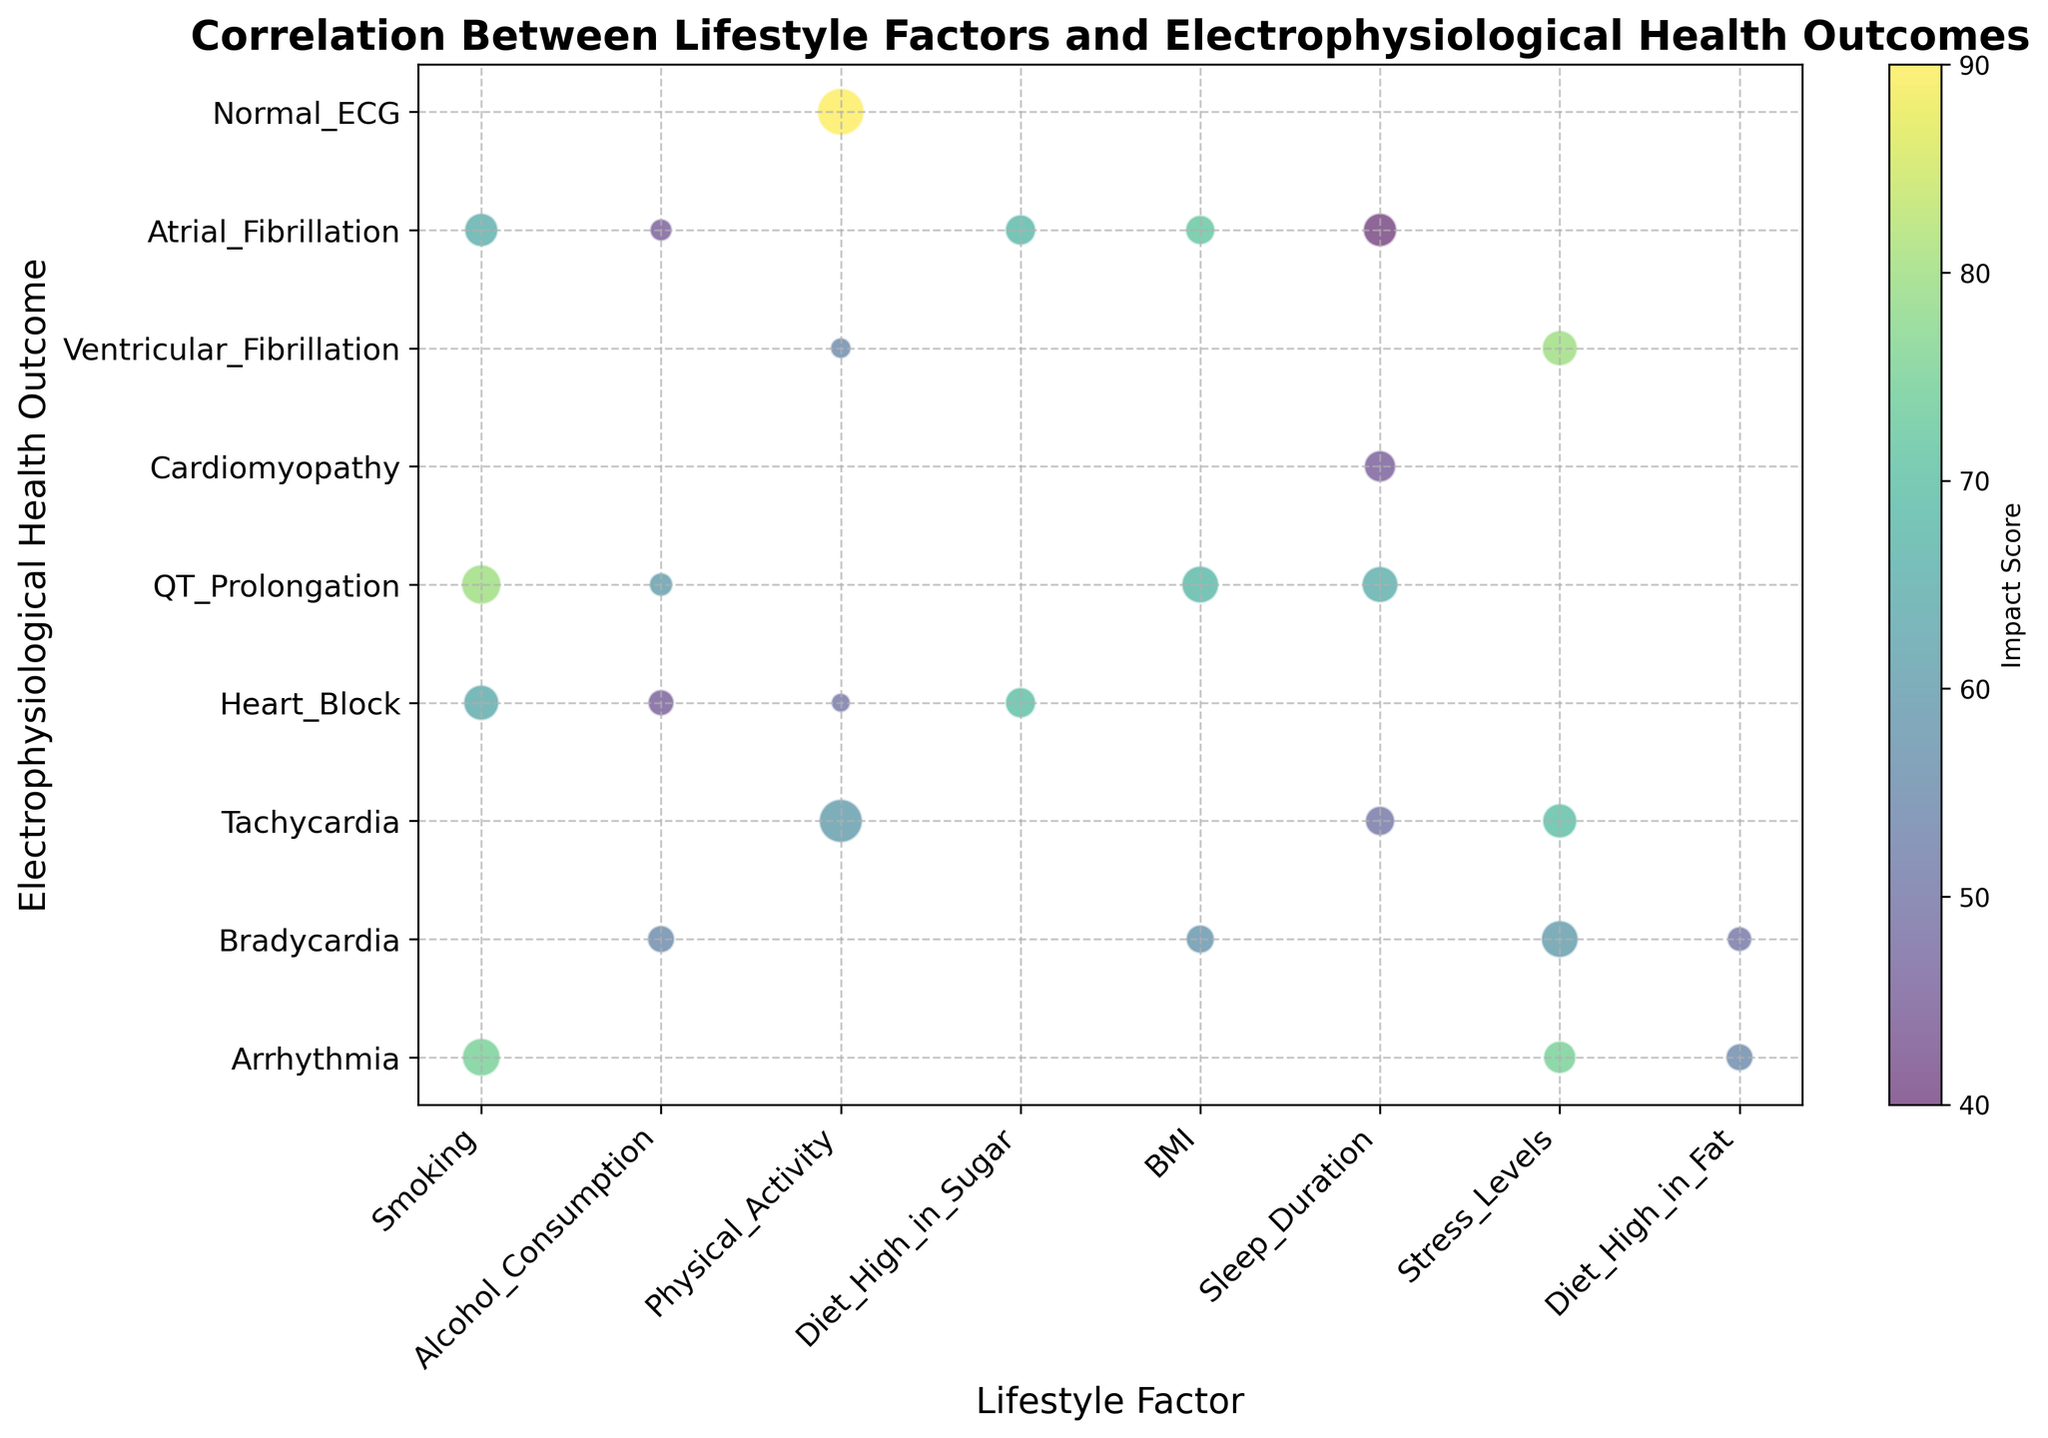What Lifestyle Factor is associated with the highest Frequency of Occurrence for QT Prolongation? To find this, we look for the bubble(s) related to QT Prolongation and identify which one is the largest. For QT Prolongation, the bubbles correspond to BMI, Alcohol Consumption, Sleep Duration, and Smoking. The largest bubble among these is Smoking.
Answer: Smoking Which Electrophysiological Health Outcome is visually the most affected by Stress Levels when considering the size of the bubbles? To determine this, we need to compare the sizes of the bubbles associated with Stress Levels. The bubbles under Stress Levels are Arrhythmia, Ventricular Fibrillation, Tachycardia, and Bradycardia. The largest bubble is associated with Ventricular Fibrillation.
Answer: Ventricular Fibrillation What is the average Impact Score for Alcohol Consumption across all Electrophysiological Health Outcomes? To calculate the average, sum the Impact Scores for Alcohol Consumption and divide by the number of occurrences. The Impact Scores are 55, 45, 60, and 45 respectively. The sum is 205. The number of occurrences is 4, so the average is 205/4 = 51.25.
Answer: 51.25 Which combination of Lifestyle Factor and Electrophysiological Health Outcome has the highest Impact Score? We review all the bubbles and identify the highest Impact Score. The highest Impact Score in the visual data is 80, and it's associated with Stress Levels and Ventricular Fibrillation as well as Smoking and QT Prolongation.
Answer: Stress Levels and Ventricular Fibrillation, Smoking and QT Prolongation Between Physical Activity and Sleep Duration, which Lifestyle Factor has a higher average Impact Score for all its associated Electrophysiological Health Outcomes? Calculate the average Impact Score for Physical Activity and Sleep Duration separately. Physical Activity's scores are 60, 90, 50, 55, totaling 255. Divided by 4, the average is 63.75. Sleep Duration's scores are 45, 40, 65, 50, totaling 200. Divided by 4, the average is 50. Therefore, Physical Activity has a higher average Impact Score.
Answer: Physical Activity Are there any Lifestyle Factors associated with the Normal ECG outcome? If so, which? Look for bubbles associated with Normal ECG, and note the corresponding Lifestyle Factor. The Lifestyle Factor for Normal ECG is Physical Activity.
Answer: Physical Activity Which Lifestyle Factor has the most diverse range of Electrophysiological Health Outcomes? Count the distinct Health Outcomes associated with each Lifestyle Factor. Physical Activity is associated with Tachycardia, Normal ECG, Heart Block, and Ventricular Fibrillation (4 outcomes). This is the highest count among all factors.
Answer: Physical Activity Comparing Arrhythmia and Atrial Fibrillation, which has a higher total Frequency of Occurrence across all Lifestyle Factors? Sum the Frequencies for each Health Outcome separately. For Arrhythmia: 23 (Smoking) + 17 (Stress Levels) + 12 (Diet High in Fat) = 52. For Atrial Fibrillation: 8 (Alcohol Consumption) + 18 (Smoking) + 15 (Diet High in Sugar) + 14 (BMI) + 18 (Sleep Duration) = 73. Therefore, Atrial Fibrillation has a higher total Frequency of Occurrence.
Answer: Atrial Fibrillation How does the color intensity (Impact Score) for Smoking and Heart Block compare to that of Smoking and QT Prolongation? Compare the color (Impact Score) of the bubbles for Smoking and Heart Block (Impact Score = 64) to Smoking and QT Prolongation (Impact Score = 80). The bubble for Smoking and QT Prolongation is darker, indicating a higher Impact Score.
Answer: Lower for Smoking and Heart Block 